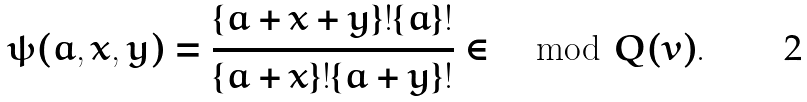<formula> <loc_0><loc_0><loc_500><loc_500>\psi ( a , x , y ) = \frac { \{ a + x + y \} ! \{ a \} ! } { \{ a + x \} ! \{ a + y \} ! } \in \mod Q ( v ) .</formula> 